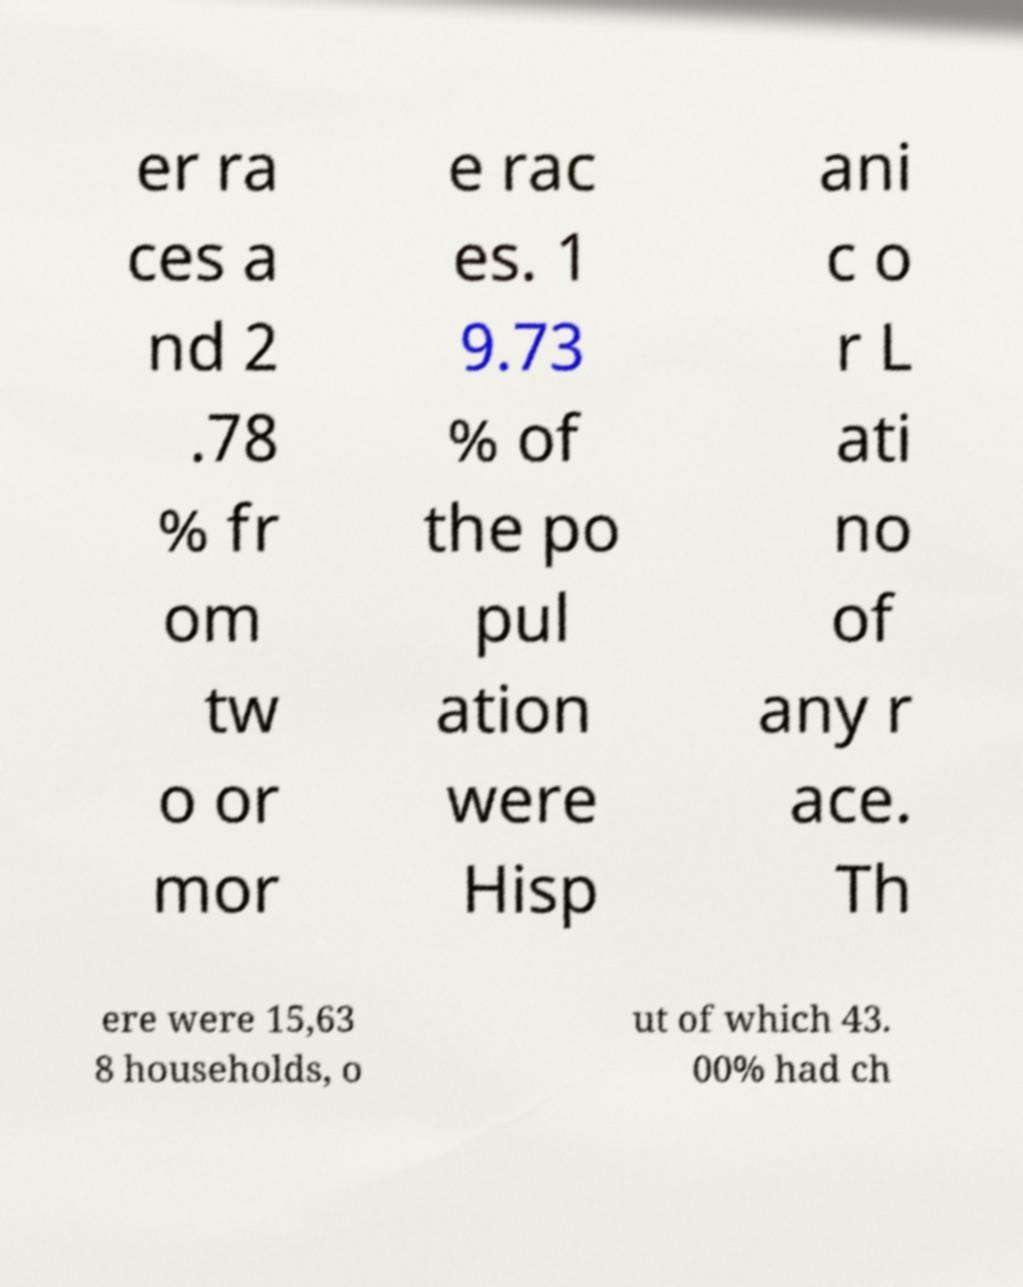Please identify and transcribe the text found in this image. er ra ces a nd 2 .78 % fr om tw o or mor e rac es. 1 9.73 % of the po pul ation were Hisp ani c o r L ati no of any r ace. Th ere were 15,63 8 households, o ut of which 43. 00% had ch 